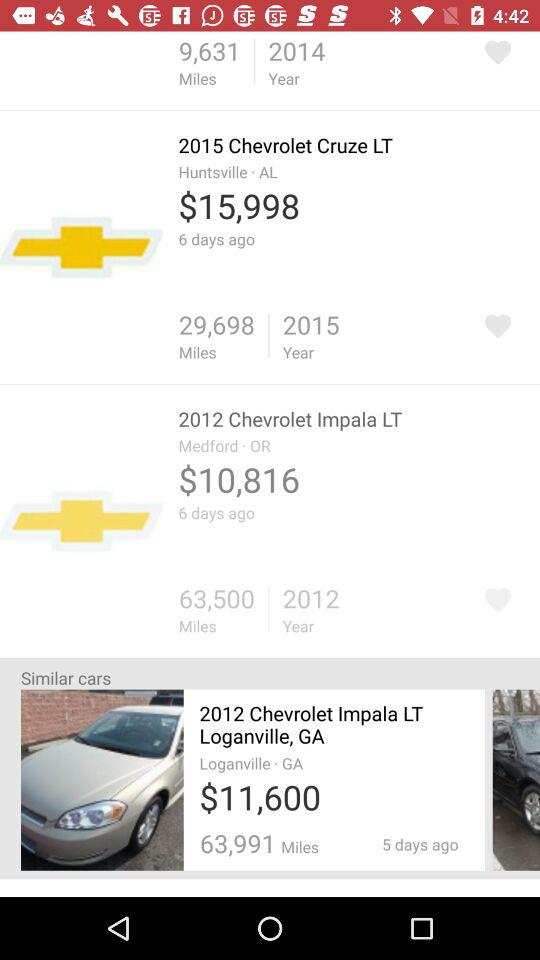Which car has more miles, the 2015 Chevrolet Cruze LT or the 2012 Chevrolet Impala LT?
Answer the question using a single word or phrase. 2012 Chevrolet Impala LT 